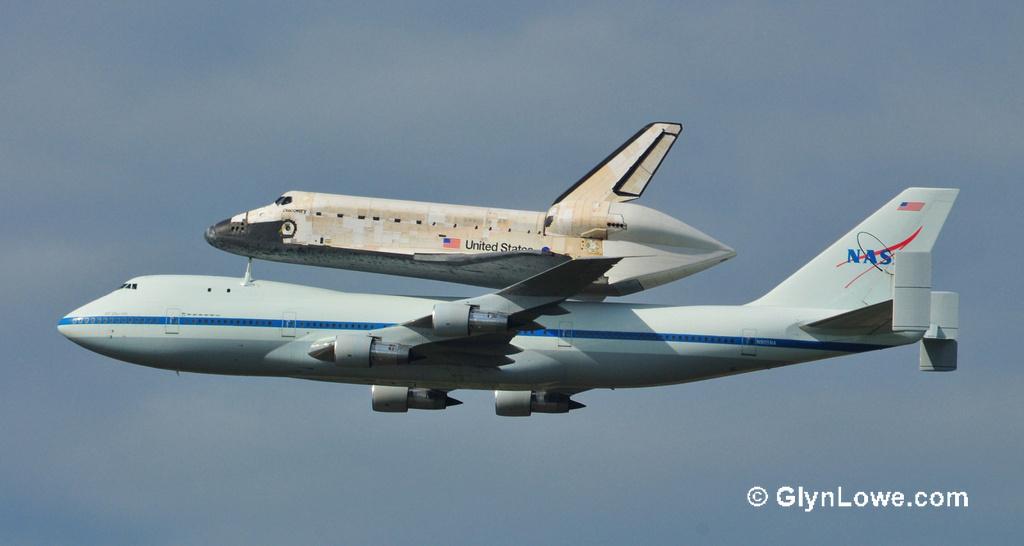What country is the small plane from?
Give a very brief answer. United states. What is the website link found in the bottom right corner?
Ensure brevity in your answer.  Glynlowe.com. 